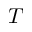<formula> <loc_0><loc_0><loc_500><loc_500>T</formula> 